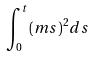Convert formula to latex. <formula><loc_0><loc_0><loc_500><loc_500>\int _ { 0 } ^ { t } ( m s ) ^ { 2 } d s</formula> 